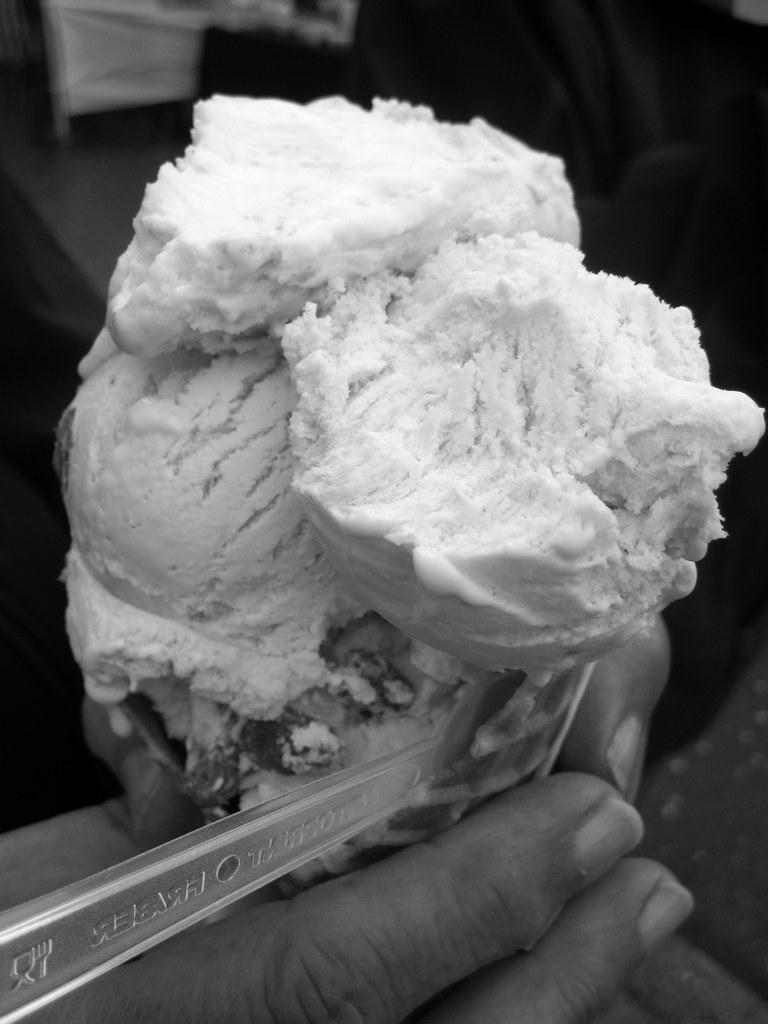Describe this image in one or two sentences. In this image we can see the hands of a person holding the ice cream. Beside him there are a few objects. 